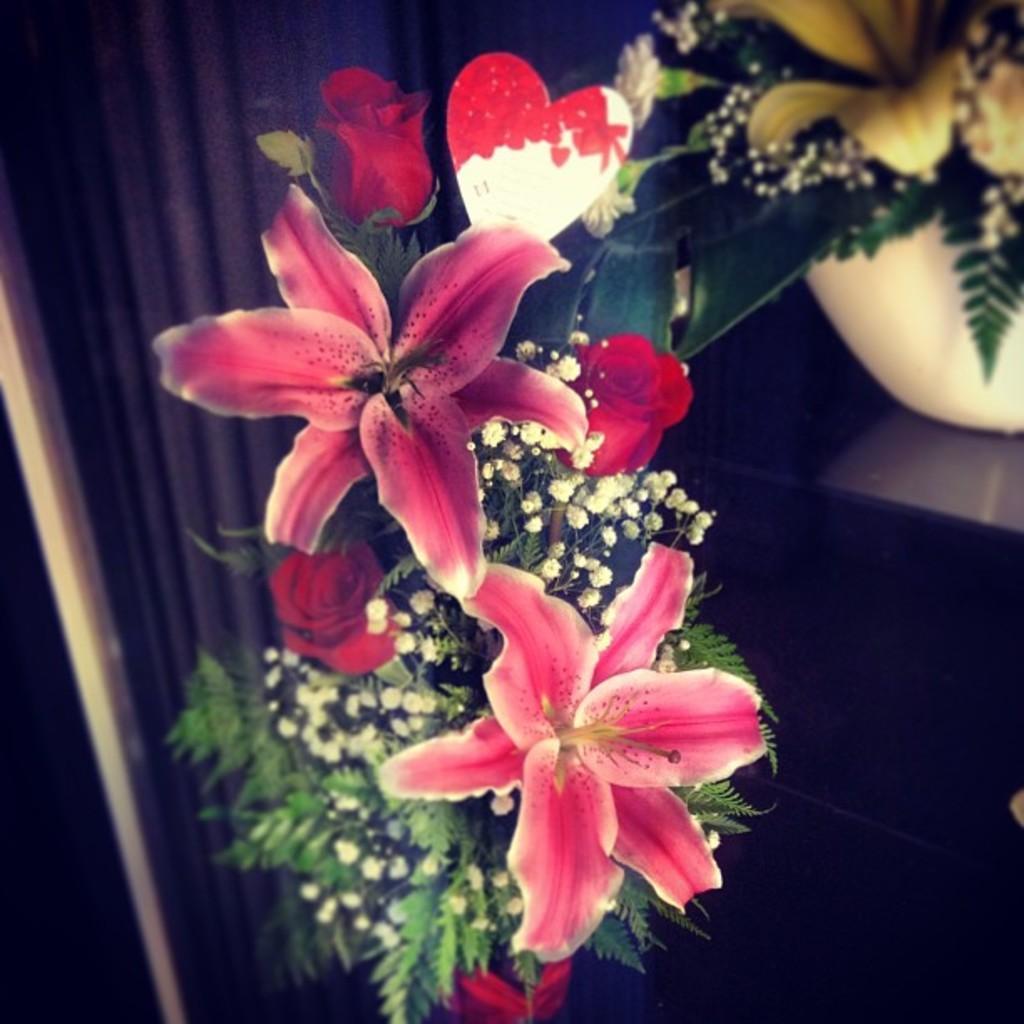In one or two sentences, can you explain what this image depicts? In this picture there are flower vases and there are pink and yellow and red colour flowers in the vases. At the back it looks like a curtain. On the right side of the image it looks like a table. 